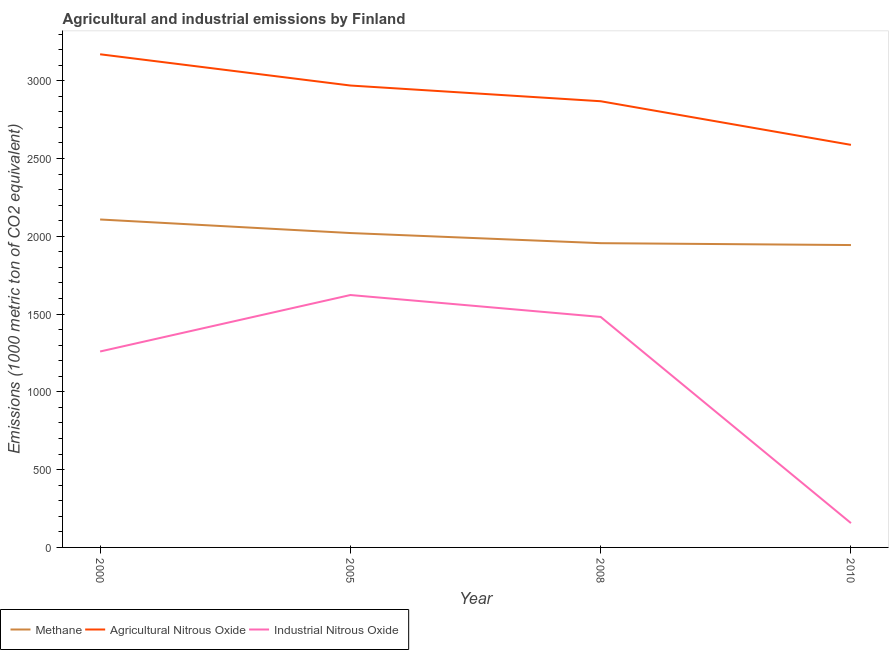Is the number of lines equal to the number of legend labels?
Give a very brief answer. Yes. What is the amount of methane emissions in 2010?
Provide a short and direct response. 1943.6. Across all years, what is the maximum amount of agricultural nitrous oxide emissions?
Keep it short and to the point. 3169.9. Across all years, what is the minimum amount of methane emissions?
Offer a terse response. 1943.6. In which year was the amount of methane emissions maximum?
Give a very brief answer. 2000. What is the total amount of agricultural nitrous oxide emissions in the graph?
Provide a short and direct response. 1.16e+04. What is the difference between the amount of agricultural nitrous oxide emissions in 2005 and that in 2008?
Offer a terse response. 101. What is the difference between the amount of industrial nitrous oxide emissions in 2008 and the amount of agricultural nitrous oxide emissions in 2005?
Provide a short and direct response. -1487.5. What is the average amount of agricultural nitrous oxide emissions per year?
Make the answer very short. 2898.62. In the year 2008, what is the difference between the amount of methane emissions and amount of industrial nitrous oxide emissions?
Make the answer very short. 474.2. In how many years, is the amount of agricultural nitrous oxide emissions greater than 600 metric ton?
Your answer should be compact. 4. What is the ratio of the amount of industrial nitrous oxide emissions in 2000 to that in 2010?
Your answer should be very brief. 8.06. Is the difference between the amount of agricultural nitrous oxide emissions in 2000 and 2008 greater than the difference between the amount of methane emissions in 2000 and 2008?
Offer a terse response. Yes. What is the difference between the highest and the second highest amount of agricultural nitrous oxide emissions?
Your answer should be very brief. 200.9. What is the difference between the highest and the lowest amount of agricultural nitrous oxide emissions?
Your answer should be compact. 582.3. Is the sum of the amount of methane emissions in 2008 and 2010 greater than the maximum amount of industrial nitrous oxide emissions across all years?
Your response must be concise. Yes. Is it the case that in every year, the sum of the amount of methane emissions and amount of agricultural nitrous oxide emissions is greater than the amount of industrial nitrous oxide emissions?
Offer a terse response. Yes. Is the amount of agricultural nitrous oxide emissions strictly less than the amount of industrial nitrous oxide emissions over the years?
Your response must be concise. No. How many lines are there?
Your response must be concise. 3. Does the graph contain grids?
Keep it short and to the point. No. How many legend labels are there?
Keep it short and to the point. 3. How are the legend labels stacked?
Provide a short and direct response. Horizontal. What is the title of the graph?
Offer a terse response. Agricultural and industrial emissions by Finland. What is the label or title of the X-axis?
Offer a very short reply. Year. What is the label or title of the Y-axis?
Keep it short and to the point. Emissions (1000 metric ton of CO2 equivalent). What is the Emissions (1000 metric ton of CO2 equivalent) of Methane in 2000?
Make the answer very short. 2107.9. What is the Emissions (1000 metric ton of CO2 equivalent) of Agricultural Nitrous Oxide in 2000?
Provide a succinct answer. 3169.9. What is the Emissions (1000 metric ton of CO2 equivalent) of Industrial Nitrous Oxide in 2000?
Provide a succinct answer. 1259.4. What is the Emissions (1000 metric ton of CO2 equivalent) in Methane in 2005?
Ensure brevity in your answer.  2020.8. What is the Emissions (1000 metric ton of CO2 equivalent) of Agricultural Nitrous Oxide in 2005?
Ensure brevity in your answer.  2969. What is the Emissions (1000 metric ton of CO2 equivalent) in Industrial Nitrous Oxide in 2005?
Your answer should be very brief. 1622.4. What is the Emissions (1000 metric ton of CO2 equivalent) in Methane in 2008?
Your answer should be very brief. 1955.7. What is the Emissions (1000 metric ton of CO2 equivalent) in Agricultural Nitrous Oxide in 2008?
Provide a short and direct response. 2868. What is the Emissions (1000 metric ton of CO2 equivalent) of Industrial Nitrous Oxide in 2008?
Your answer should be very brief. 1481.5. What is the Emissions (1000 metric ton of CO2 equivalent) in Methane in 2010?
Your response must be concise. 1943.6. What is the Emissions (1000 metric ton of CO2 equivalent) of Agricultural Nitrous Oxide in 2010?
Ensure brevity in your answer.  2587.6. What is the Emissions (1000 metric ton of CO2 equivalent) in Industrial Nitrous Oxide in 2010?
Your response must be concise. 156.3. Across all years, what is the maximum Emissions (1000 metric ton of CO2 equivalent) in Methane?
Offer a very short reply. 2107.9. Across all years, what is the maximum Emissions (1000 metric ton of CO2 equivalent) of Agricultural Nitrous Oxide?
Your answer should be compact. 3169.9. Across all years, what is the maximum Emissions (1000 metric ton of CO2 equivalent) in Industrial Nitrous Oxide?
Your answer should be compact. 1622.4. Across all years, what is the minimum Emissions (1000 metric ton of CO2 equivalent) in Methane?
Your answer should be very brief. 1943.6. Across all years, what is the minimum Emissions (1000 metric ton of CO2 equivalent) of Agricultural Nitrous Oxide?
Your answer should be compact. 2587.6. Across all years, what is the minimum Emissions (1000 metric ton of CO2 equivalent) of Industrial Nitrous Oxide?
Make the answer very short. 156.3. What is the total Emissions (1000 metric ton of CO2 equivalent) of Methane in the graph?
Give a very brief answer. 8028. What is the total Emissions (1000 metric ton of CO2 equivalent) in Agricultural Nitrous Oxide in the graph?
Your answer should be very brief. 1.16e+04. What is the total Emissions (1000 metric ton of CO2 equivalent) in Industrial Nitrous Oxide in the graph?
Provide a short and direct response. 4519.6. What is the difference between the Emissions (1000 metric ton of CO2 equivalent) in Methane in 2000 and that in 2005?
Your answer should be very brief. 87.1. What is the difference between the Emissions (1000 metric ton of CO2 equivalent) in Agricultural Nitrous Oxide in 2000 and that in 2005?
Your answer should be very brief. 200.9. What is the difference between the Emissions (1000 metric ton of CO2 equivalent) in Industrial Nitrous Oxide in 2000 and that in 2005?
Your response must be concise. -363. What is the difference between the Emissions (1000 metric ton of CO2 equivalent) in Methane in 2000 and that in 2008?
Ensure brevity in your answer.  152.2. What is the difference between the Emissions (1000 metric ton of CO2 equivalent) of Agricultural Nitrous Oxide in 2000 and that in 2008?
Offer a terse response. 301.9. What is the difference between the Emissions (1000 metric ton of CO2 equivalent) in Industrial Nitrous Oxide in 2000 and that in 2008?
Your answer should be very brief. -222.1. What is the difference between the Emissions (1000 metric ton of CO2 equivalent) in Methane in 2000 and that in 2010?
Your response must be concise. 164.3. What is the difference between the Emissions (1000 metric ton of CO2 equivalent) of Agricultural Nitrous Oxide in 2000 and that in 2010?
Ensure brevity in your answer.  582.3. What is the difference between the Emissions (1000 metric ton of CO2 equivalent) of Industrial Nitrous Oxide in 2000 and that in 2010?
Your answer should be compact. 1103.1. What is the difference between the Emissions (1000 metric ton of CO2 equivalent) of Methane in 2005 and that in 2008?
Make the answer very short. 65.1. What is the difference between the Emissions (1000 metric ton of CO2 equivalent) of Agricultural Nitrous Oxide in 2005 and that in 2008?
Keep it short and to the point. 101. What is the difference between the Emissions (1000 metric ton of CO2 equivalent) of Industrial Nitrous Oxide in 2005 and that in 2008?
Provide a short and direct response. 140.9. What is the difference between the Emissions (1000 metric ton of CO2 equivalent) of Methane in 2005 and that in 2010?
Make the answer very short. 77.2. What is the difference between the Emissions (1000 metric ton of CO2 equivalent) of Agricultural Nitrous Oxide in 2005 and that in 2010?
Your response must be concise. 381.4. What is the difference between the Emissions (1000 metric ton of CO2 equivalent) of Industrial Nitrous Oxide in 2005 and that in 2010?
Provide a short and direct response. 1466.1. What is the difference between the Emissions (1000 metric ton of CO2 equivalent) in Methane in 2008 and that in 2010?
Your answer should be compact. 12.1. What is the difference between the Emissions (1000 metric ton of CO2 equivalent) of Agricultural Nitrous Oxide in 2008 and that in 2010?
Offer a terse response. 280.4. What is the difference between the Emissions (1000 metric ton of CO2 equivalent) in Industrial Nitrous Oxide in 2008 and that in 2010?
Your answer should be compact. 1325.2. What is the difference between the Emissions (1000 metric ton of CO2 equivalent) of Methane in 2000 and the Emissions (1000 metric ton of CO2 equivalent) of Agricultural Nitrous Oxide in 2005?
Provide a short and direct response. -861.1. What is the difference between the Emissions (1000 metric ton of CO2 equivalent) of Methane in 2000 and the Emissions (1000 metric ton of CO2 equivalent) of Industrial Nitrous Oxide in 2005?
Your answer should be very brief. 485.5. What is the difference between the Emissions (1000 metric ton of CO2 equivalent) in Agricultural Nitrous Oxide in 2000 and the Emissions (1000 metric ton of CO2 equivalent) in Industrial Nitrous Oxide in 2005?
Your answer should be compact. 1547.5. What is the difference between the Emissions (1000 metric ton of CO2 equivalent) in Methane in 2000 and the Emissions (1000 metric ton of CO2 equivalent) in Agricultural Nitrous Oxide in 2008?
Ensure brevity in your answer.  -760.1. What is the difference between the Emissions (1000 metric ton of CO2 equivalent) in Methane in 2000 and the Emissions (1000 metric ton of CO2 equivalent) in Industrial Nitrous Oxide in 2008?
Ensure brevity in your answer.  626.4. What is the difference between the Emissions (1000 metric ton of CO2 equivalent) in Agricultural Nitrous Oxide in 2000 and the Emissions (1000 metric ton of CO2 equivalent) in Industrial Nitrous Oxide in 2008?
Provide a succinct answer. 1688.4. What is the difference between the Emissions (1000 metric ton of CO2 equivalent) in Methane in 2000 and the Emissions (1000 metric ton of CO2 equivalent) in Agricultural Nitrous Oxide in 2010?
Your answer should be compact. -479.7. What is the difference between the Emissions (1000 metric ton of CO2 equivalent) of Methane in 2000 and the Emissions (1000 metric ton of CO2 equivalent) of Industrial Nitrous Oxide in 2010?
Offer a terse response. 1951.6. What is the difference between the Emissions (1000 metric ton of CO2 equivalent) in Agricultural Nitrous Oxide in 2000 and the Emissions (1000 metric ton of CO2 equivalent) in Industrial Nitrous Oxide in 2010?
Provide a short and direct response. 3013.6. What is the difference between the Emissions (1000 metric ton of CO2 equivalent) of Methane in 2005 and the Emissions (1000 metric ton of CO2 equivalent) of Agricultural Nitrous Oxide in 2008?
Provide a short and direct response. -847.2. What is the difference between the Emissions (1000 metric ton of CO2 equivalent) in Methane in 2005 and the Emissions (1000 metric ton of CO2 equivalent) in Industrial Nitrous Oxide in 2008?
Provide a succinct answer. 539.3. What is the difference between the Emissions (1000 metric ton of CO2 equivalent) of Agricultural Nitrous Oxide in 2005 and the Emissions (1000 metric ton of CO2 equivalent) of Industrial Nitrous Oxide in 2008?
Keep it short and to the point. 1487.5. What is the difference between the Emissions (1000 metric ton of CO2 equivalent) in Methane in 2005 and the Emissions (1000 metric ton of CO2 equivalent) in Agricultural Nitrous Oxide in 2010?
Your answer should be compact. -566.8. What is the difference between the Emissions (1000 metric ton of CO2 equivalent) of Methane in 2005 and the Emissions (1000 metric ton of CO2 equivalent) of Industrial Nitrous Oxide in 2010?
Your response must be concise. 1864.5. What is the difference between the Emissions (1000 metric ton of CO2 equivalent) of Agricultural Nitrous Oxide in 2005 and the Emissions (1000 metric ton of CO2 equivalent) of Industrial Nitrous Oxide in 2010?
Offer a very short reply. 2812.7. What is the difference between the Emissions (1000 metric ton of CO2 equivalent) of Methane in 2008 and the Emissions (1000 metric ton of CO2 equivalent) of Agricultural Nitrous Oxide in 2010?
Your answer should be compact. -631.9. What is the difference between the Emissions (1000 metric ton of CO2 equivalent) of Methane in 2008 and the Emissions (1000 metric ton of CO2 equivalent) of Industrial Nitrous Oxide in 2010?
Offer a terse response. 1799.4. What is the difference between the Emissions (1000 metric ton of CO2 equivalent) of Agricultural Nitrous Oxide in 2008 and the Emissions (1000 metric ton of CO2 equivalent) of Industrial Nitrous Oxide in 2010?
Keep it short and to the point. 2711.7. What is the average Emissions (1000 metric ton of CO2 equivalent) in Methane per year?
Offer a very short reply. 2007. What is the average Emissions (1000 metric ton of CO2 equivalent) of Agricultural Nitrous Oxide per year?
Provide a short and direct response. 2898.62. What is the average Emissions (1000 metric ton of CO2 equivalent) in Industrial Nitrous Oxide per year?
Your answer should be compact. 1129.9. In the year 2000, what is the difference between the Emissions (1000 metric ton of CO2 equivalent) in Methane and Emissions (1000 metric ton of CO2 equivalent) in Agricultural Nitrous Oxide?
Offer a terse response. -1062. In the year 2000, what is the difference between the Emissions (1000 metric ton of CO2 equivalent) in Methane and Emissions (1000 metric ton of CO2 equivalent) in Industrial Nitrous Oxide?
Provide a succinct answer. 848.5. In the year 2000, what is the difference between the Emissions (1000 metric ton of CO2 equivalent) of Agricultural Nitrous Oxide and Emissions (1000 metric ton of CO2 equivalent) of Industrial Nitrous Oxide?
Your answer should be compact. 1910.5. In the year 2005, what is the difference between the Emissions (1000 metric ton of CO2 equivalent) of Methane and Emissions (1000 metric ton of CO2 equivalent) of Agricultural Nitrous Oxide?
Your response must be concise. -948.2. In the year 2005, what is the difference between the Emissions (1000 metric ton of CO2 equivalent) of Methane and Emissions (1000 metric ton of CO2 equivalent) of Industrial Nitrous Oxide?
Make the answer very short. 398.4. In the year 2005, what is the difference between the Emissions (1000 metric ton of CO2 equivalent) in Agricultural Nitrous Oxide and Emissions (1000 metric ton of CO2 equivalent) in Industrial Nitrous Oxide?
Provide a short and direct response. 1346.6. In the year 2008, what is the difference between the Emissions (1000 metric ton of CO2 equivalent) of Methane and Emissions (1000 metric ton of CO2 equivalent) of Agricultural Nitrous Oxide?
Give a very brief answer. -912.3. In the year 2008, what is the difference between the Emissions (1000 metric ton of CO2 equivalent) of Methane and Emissions (1000 metric ton of CO2 equivalent) of Industrial Nitrous Oxide?
Offer a terse response. 474.2. In the year 2008, what is the difference between the Emissions (1000 metric ton of CO2 equivalent) in Agricultural Nitrous Oxide and Emissions (1000 metric ton of CO2 equivalent) in Industrial Nitrous Oxide?
Keep it short and to the point. 1386.5. In the year 2010, what is the difference between the Emissions (1000 metric ton of CO2 equivalent) in Methane and Emissions (1000 metric ton of CO2 equivalent) in Agricultural Nitrous Oxide?
Offer a very short reply. -644. In the year 2010, what is the difference between the Emissions (1000 metric ton of CO2 equivalent) of Methane and Emissions (1000 metric ton of CO2 equivalent) of Industrial Nitrous Oxide?
Ensure brevity in your answer.  1787.3. In the year 2010, what is the difference between the Emissions (1000 metric ton of CO2 equivalent) in Agricultural Nitrous Oxide and Emissions (1000 metric ton of CO2 equivalent) in Industrial Nitrous Oxide?
Provide a succinct answer. 2431.3. What is the ratio of the Emissions (1000 metric ton of CO2 equivalent) in Methane in 2000 to that in 2005?
Offer a very short reply. 1.04. What is the ratio of the Emissions (1000 metric ton of CO2 equivalent) in Agricultural Nitrous Oxide in 2000 to that in 2005?
Provide a succinct answer. 1.07. What is the ratio of the Emissions (1000 metric ton of CO2 equivalent) of Industrial Nitrous Oxide in 2000 to that in 2005?
Your answer should be very brief. 0.78. What is the ratio of the Emissions (1000 metric ton of CO2 equivalent) in Methane in 2000 to that in 2008?
Provide a short and direct response. 1.08. What is the ratio of the Emissions (1000 metric ton of CO2 equivalent) of Agricultural Nitrous Oxide in 2000 to that in 2008?
Give a very brief answer. 1.11. What is the ratio of the Emissions (1000 metric ton of CO2 equivalent) of Industrial Nitrous Oxide in 2000 to that in 2008?
Give a very brief answer. 0.85. What is the ratio of the Emissions (1000 metric ton of CO2 equivalent) in Methane in 2000 to that in 2010?
Your answer should be compact. 1.08. What is the ratio of the Emissions (1000 metric ton of CO2 equivalent) of Agricultural Nitrous Oxide in 2000 to that in 2010?
Your answer should be very brief. 1.23. What is the ratio of the Emissions (1000 metric ton of CO2 equivalent) of Industrial Nitrous Oxide in 2000 to that in 2010?
Your answer should be very brief. 8.06. What is the ratio of the Emissions (1000 metric ton of CO2 equivalent) of Agricultural Nitrous Oxide in 2005 to that in 2008?
Offer a very short reply. 1.04. What is the ratio of the Emissions (1000 metric ton of CO2 equivalent) in Industrial Nitrous Oxide in 2005 to that in 2008?
Offer a very short reply. 1.1. What is the ratio of the Emissions (1000 metric ton of CO2 equivalent) of Methane in 2005 to that in 2010?
Offer a very short reply. 1.04. What is the ratio of the Emissions (1000 metric ton of CO2 equivalent) of Agricultural Nitrous Oxide in 2005 to that in 2010?
Provide a short and direct response. 1.15. What is the ratio of the Emissions (1000 metric ton of CO2 equivalent) of Industrial Nitrous Oxide in 2005 to that in 2010?
Give a very brief answer. 10.38. What is the ratio of the Emissions (1000 metric ton of CO2 equivalent) in Agricultural Nitrous Oxide in 2008 to that in 2010?
Give a very brief answer. 1.11. What is the ratio of the Emissions (1000 metric ton of CO2 equivalent) in Industrial Nitrous Oxide in 2008 to that in 2010?
Provide a succinct answer. 9.48. What is the difference between the highest and the second highest Emissions (1000 metric ton of CO2 equivalent) in Methane?
Offer a very short reply. 87.1. What is the difference between the highest and the second highest Emissions (1000 metric ton of CO2 equivalent) of Agricultural Nitrous Oxide?
Your response must be concise. 200.9. What is the difference between the highest and the second highest Emissions (1000 metric ton of CO2 equivalent) in Industrial Nitrous Oxide?
Ensure brevity in your answer.  140.9. What is the difference between the highest and the lowest Emissions (1000 metric ton of CO2 equivalent) of Methane?
Provide a succinct answer. 164.3. What is the difference between the highest and the lowest Emissions (1000 metric ton of CO2 equivalent) of Agricultural Nitrous Oxide?
Keep it short and to the point. 582.3. What is the difference between the highest and the lowest Emissions (1000 metric ton of CO2 equivalent) in Industrial Nitrous Oxide?
Offer a terse response. 1466.1. 